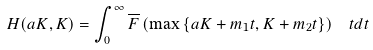Convert formula to latex. <formula><loc_0><loc_0><loc_500><loc_500>H ( a K , K ) = \int _ { 0 } ^ { \infty } \overline { F } \left ( \max \left \{ a K + m _ { 1 } t , K + m _ { 2 } t \right \} \right ) \, \ t d t</formula> 